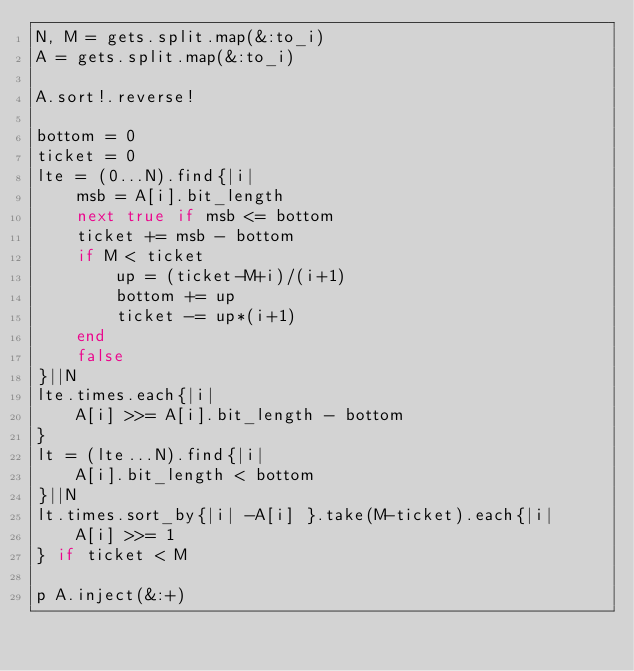<code> <loc_0><loc_0><loc_500><loc_500><_Ruby_>N, M = gets.split.map(&:to_i)
A = gets.split.map(&:to_i)

A.sort!.reverse!

bottom = 0
ticket = 0
lte = (0...N).find{|i|
	msb = A[i].bit_length
	next true if msb <= bottom
 	ticket += msb - bottom
	if M < ticket
		up = (ticket-M+i)/(i+1)
		bottom += up
		ticket -= up*(i+1)
	end
	false
}||N
lte.times.each{|i|
	A[i] >>= A[i].bit_length - bottom
}
lt = (lte...N).find{|i|
	A[i].bit_length < bottom
}||N
lt.times.sort_by{|i| -A[i] }.take(M-ticket).each{|i|
	A[i] >>= 1
} if ticket < M

p A.inject(&:+)
</code> 